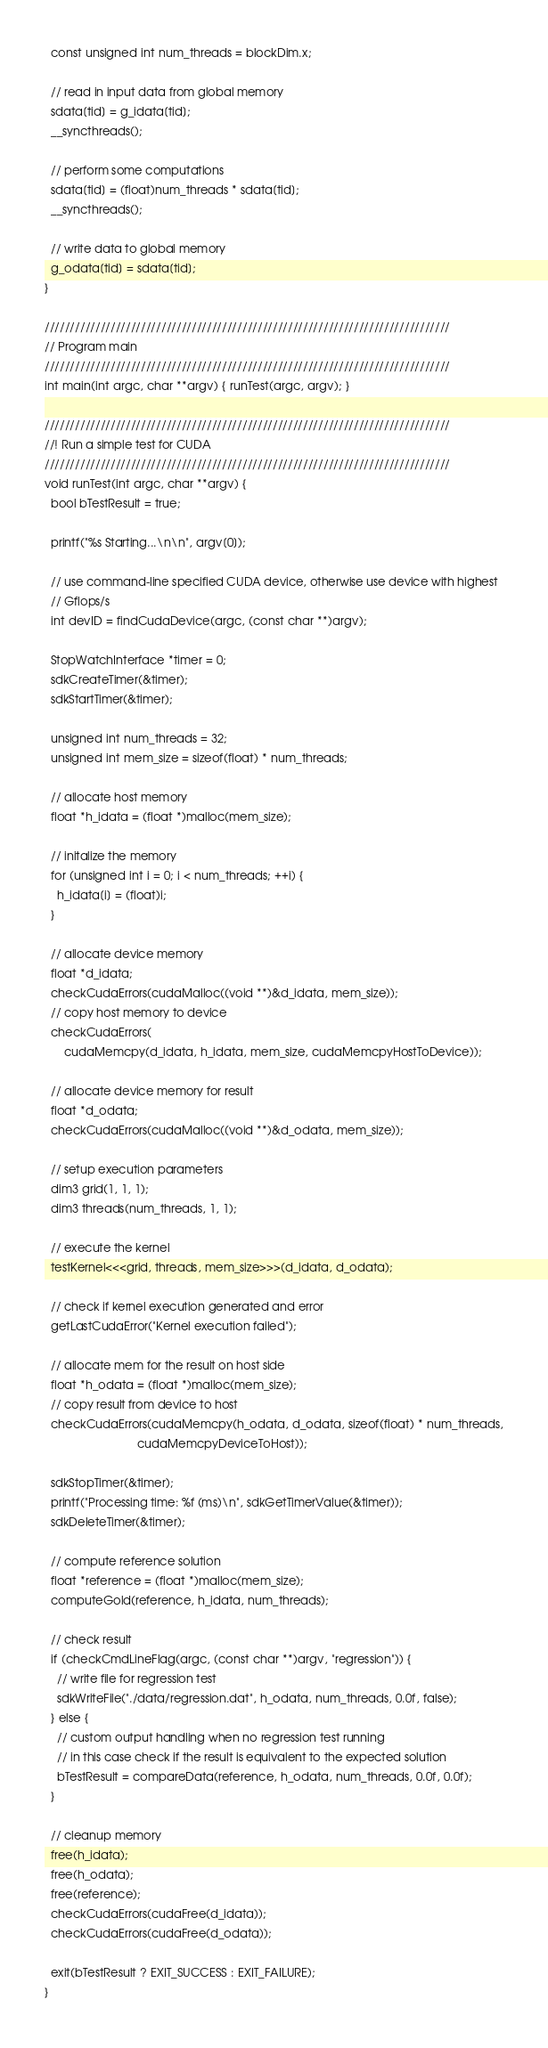<code> <loc_0><loc_0><loc_500><loc_500><_Cuda_>  const unsigned int num_threads = blockDim.x;

  // read in input data from global memory
  sdata[tid] = g_idata[tid];
  __syncthreads();

  // perform some computations
  sdata[tid] = (float)num_threads * sdata[tid];
  __syncthreads();

  // write data to global memory
  g_odata[tid] = sdata[tid];
}

////////////////////////////////////////////////////////////////////////////////
// Program main
////////////////////////////////////////////////////////////////////////////////
int main(int argc, char **argv) { runTest(argc, argv); }

////////////////////////////////////////////////////////////////////////////////
//! Run a simple test for CUDA
////////////////////////////////////////////////////////////////////////////////
void runTest(int argc, char **argv) {
  bool bTestResult = true;

  printf("%s Starting...\n\n", argv[0]);

  // use command-line specified CUDA device, otherwise use device with highest
  // Gflops/s
  int devID = findCudaDevice(argc, (const char **)argv);

  StopWatchInterface *timer = 0;
  sdkCreateTimer(&timer);
  sdkStartTimer(&timer);

  unsigned int num_threads = 32;
  unsigned int mem_size = sizeof(float) * num_threads;

  // allocate host memory
  float *h_idata = (float *)malloc(mem_size);

  // initalize the memory
  for (unsigned int i = 0; i < num_threads; ++i) {
    h_idata[i] = (float)i;
  }

  // allocate device memory
  float *d_idata;
  checkCudaErrors(cudaMalloc((void **)&d_idata, mem_size));
  // copy host memory to device
  checkCudaErrors(
      cudaMemcpy(d_idata, h_idata, mem_size, cudaMemcpyHostToDevice));

  // allocate device memory for result
  float *d_odata;
  checkCudaErrors(cudaMalloc((void **)&d_odata, mem_size));

  // setup execution parameters
  dim3 grid(1, 1, 1);
  dim3 threads(num_threads, 1, 1);

  // execute the kernel
  testKernel<<<grid, threads, mem_size>>>(d_idata, d_odata);

  // check if kernel execution generated and error
  getLastCudaError("Kernel execution failed");

  // allocate mem for the result on host side
  float *h_odata = (float *)malloc(mem_size);
  // copy result from device to host
  checkCudaErrors(cudaMemcpy(h_odata, d_odata, sizeof(float) * num_threads,
                             cudaMemcpyDeviceToHost));

  sdkStopTimer(&timer);
  printf("Processing time: %f (ms)\n", sdkGetTimerValue(&timer));
  sdkDeleteTimer(&timer);

  // compute reference solution
  float *reference = (float *)malloc(mem_size);
  computeGold(reference, h_idata, num_threads);

  // check result
  if (checkCmdLineFlag(argc, (const char **)argv, "regression")) {
    // write file for regression test
    sdkWriteFile("./data/regression.dat", h_odata, num_threads, 0.0f, false);
  } else {
    // custom output handling when no regression test running
    // in this case check if the result is equivalent to the expected solution
    bTestResult = compareData(reference, h_odata, num_threads, 0.0f, 0.0f);
  }

  // cleanup memory
  free(h_idata);
  free(h_odata);
  free(reference);
  checkCudaErrors(cudaFree(d_idata));
  checkCudaErrors(cudaFree(d_odata));

  exit(bTestResult ? EXIT_SUCCESS : EXIT_FAILURE);
}
</code> 